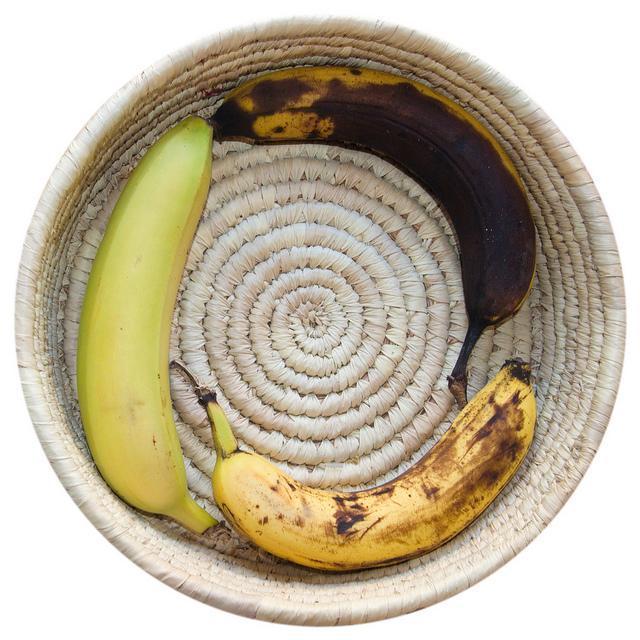How many bananas are in the photo?
Give a very brief answer. 3. 